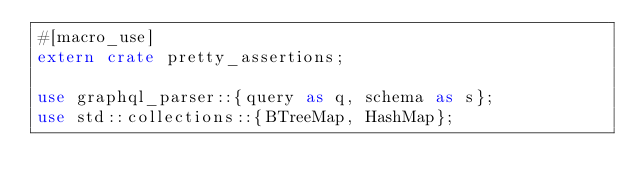<code> <loc_0><loc_0><loc_500><loc_500><_Rust_>#[macro_use]
extern crate pretty_assertions;

use graphql_parser::{query as q, schema as s};
use std::collections::{BTreeMap, HashMap};
</code> 